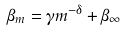<formula> <loc_0><loc_0><loc_500><loc_500>\beta _ { m } = \gamma m ^ { - \delta } + \beta _ { \infty }</formula> 